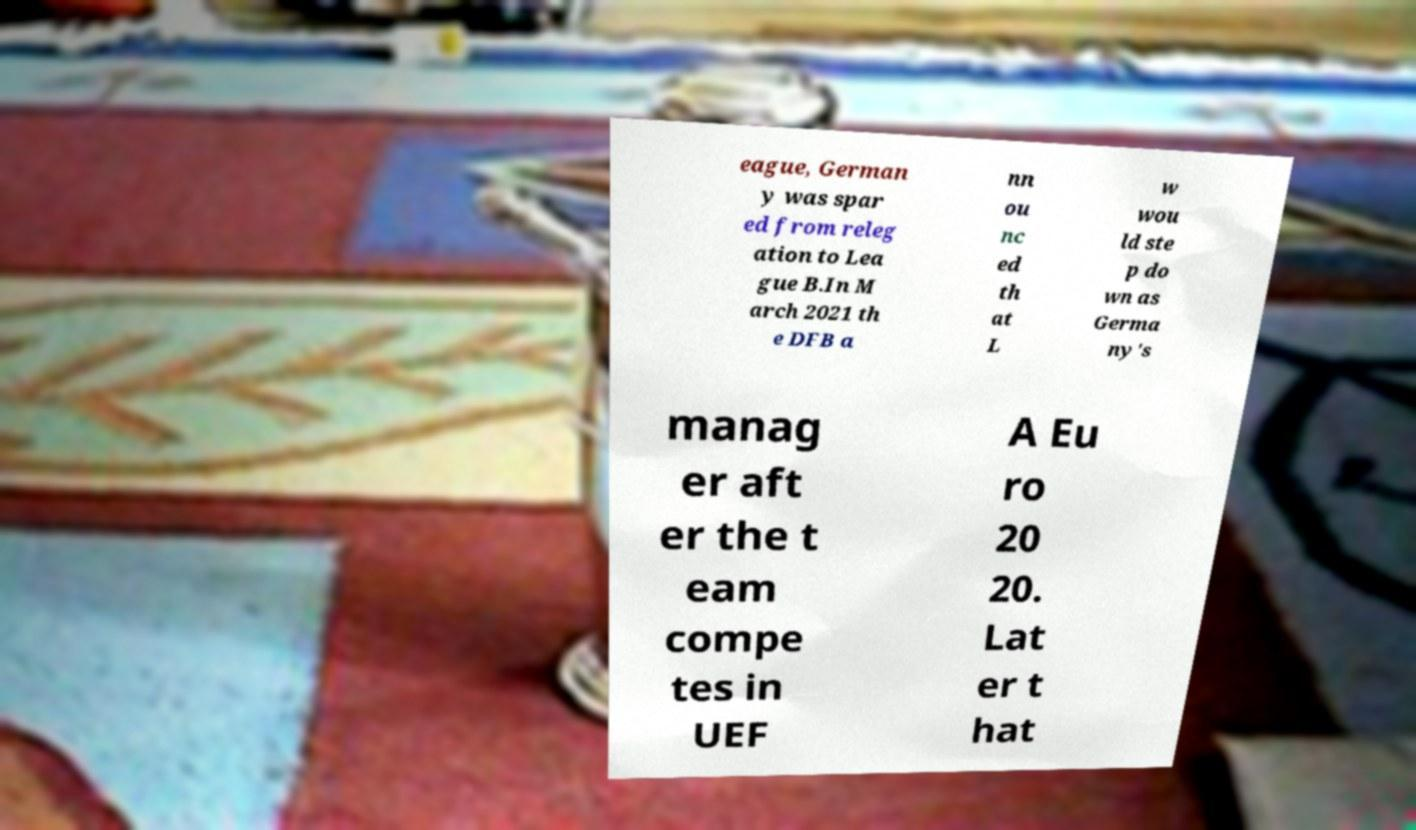Can you read and provide the text displayed in the image?This photo seems to have some interesting text. Can you extract and type it out for me? eague, German y was spar ed from releg ation to Lea gue B.In M arch 2021 th e DFB a nn ou nc ed th at L w wou ld ste p do wn as Germa ny's manag er aft er the t eam compe tes in UEF A Eu ro 20 20. Lat er t hat 